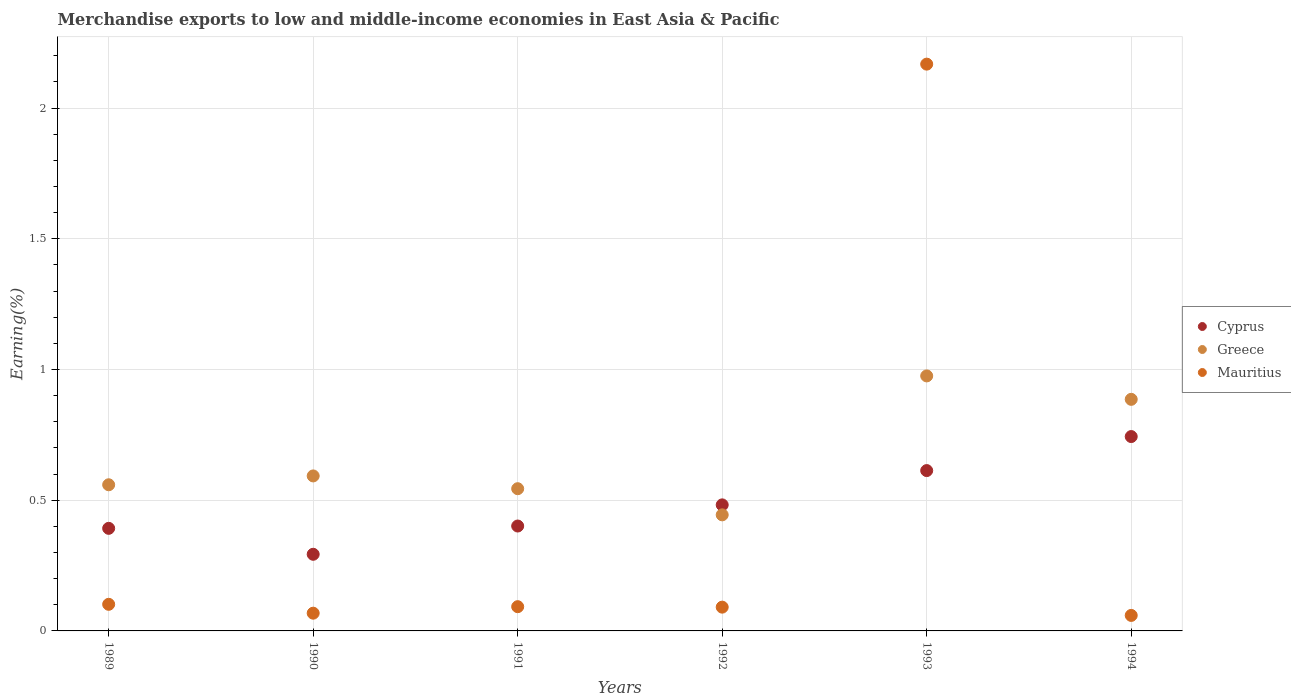Is the number of dotlines equal to the number of legend labels?
Your answer should be very brief. Yes. What is the percentage of amount earned from merchandise exports in Mauritius in 1994?
Provide a short and direct response. 0.06. Across all years, what is the maximum percentage of amount earned from merchandise exports in Cyprus?
Offer a very short reply. 0.74. Across all years, what is the minimum percentage of amount earned from merchandise exports in Mauritius?
Make the answer very short. 0.06. What is the total percentage of amount earned from merchandise exports in Mauritius in the graph?
Give a very brief answer. 2.58. What is the difference between the percentage of amount earned from merchandise exports in Cyprus in 1989 and that in 1991?
Your answer should be compact. -0.01. What is the difference between the percentage of amount earned from merchandise exports in Cyprus in 1991 and the percentage of amount earned from merchandise exports in Greece in 1992?
Offer a terse response. -0.04. What is the average percentage of amount earned from merchandise exports in Greece per year?
Make the answer very short. 0.67. In the year 1992, what is the difference between the percentage of amount earned from merchandise exports in Cyprus and percentage of amount earned from merchandise exports in Mauritius?
Provide a short and direct response. 0.39. In how many years, is the percentage of amount earned from merchandise exports in Mauritius greater than 0.30000000000000004 %?
Provide a short and direct response. 1. What is the ratio of the percentage of amount earned from merchandise exports in Greece in 1993 to that in 1994?
Make the answer very short. 1.1. Is the percentage of amount earned from merchandise exports in Greece in 1989 less than that in 1992?
Give a very brief answer. No. What is the difference between the highest and the second highest percentage of amount earned from merchandise exports in Greece?
Provide a short and direct response. 0.09. What is the difference between the highest and the lowest percentage of amount earned from merchandise exports in Greece?
Your answer should be very brief. 0.53. Is the sum of the percentage of amount earned from merchandise exports in Greece in 1990 and 1993 greater than the maximum percentage of amount earned from merchandise exports in Cyprus across all years?
Keep it short and to the point. Yes. Is the percentage of amount earned from merchandise exports in Cyprus strictly greater than the percentage of amount earned from merchandise exports in Mauritius over the years?
Your response must be concise. No. How many dotlines are there?
Make the answer very short. 3. What is the difference between two consecutive major ticks on the Y-axis?
Your response must be concise. 0.5. Does the graph contain any zero values?
Your answer should be compact. No. Where does the legend appear in the graph?
Make the answer very short. Center right. How many legend labels are there?
Provide a short and direct response. 3. How are the legend labels stacked?
Provide a short and direct response. Vertical. What is the title of the graph?
Your answer should be compact. Merchandise exports to low and middle-income economies in East Asia & Pacific. Does "Tonga" appear as one of the legend labels in the graph?
Your response must be concise. No. What is the label or title of the Y-axis?
Give a very brief answer. Earning(%). What is the Earning(%) in Cyprus in 1989?
Offer a very short reply. 0.39. What is the Earning(%) of Greece in 1989?
Offer a terse response. 0.56. What is the Earning(%) in Mauritius in 1989?
Offer a very short reply. 0.1. What is the Earning(%) in Cyprus in 1990?
Offer a terse response. 0.29. What is the Earning(%) in Greece in 1990?
Offer a very short reply. 0.59. What is the Earning(%) of Mauritius in 1990?
Your answer should be compact. 0.07. What is the Earning(%) of Cyprus in 1991?
Make the answer very short. 0.4. What is the Earning(%) of Greece in 1991?
Ensure brevity in your answer.  0.54. What is the Earning(%) in Mauritius in 1991?
Ensure brevity in your answer.  0.09. What is the Earning(%) of Cyprus in 1992?
Provide a short and direct response. 0.48. What is the Earning(%) in Greece in 1992?
Your response must be concise. 0.44. What is the Earning(%) of Mauritius in 1992?
Your response must be concise. 0.09. What is the Earning(%) of Cyprus in 1993?
Ensure brevity in your answer.  0.61. What is the Earning(%) of Greece in 1993?
Offer a very short reply. 0.98. What is the Earning(%) in Mauritius in 1993?
Your response must be concise. 2.17. What is the Earning(%) in Cyprus in 1994?
Your answer should be very brief. 0.74. What is the Earning(%) of Greece in 1994?
Your answer should be very brief. 0.89. What is the Earning(%) in Mauritius in 1994?
Provide a succinct answer. 0.06. Across all years, what is the maximum Earning(%) of Cyprus?
Make the answer very short. 0.74. Across all years, what is the maximum Earning(%) in Greece?
Ensure brevity in your answer.  0.98. Across all years, what is the maximum Earning(%) of Mauritius?
Offer a very short reply. 2.17. Across all years, what is the minimum Earning(%) in Cyprus?
Your answer should be very brief. 0.29. Across all years, what is the minimum Earning(%) in Greece?
Provide a short and direct response. 0.44. Across all years, what is the minimum Earning(%) in Mauritius?
Offer a terse response. 0.06. What is the total Earning(%) in Cyprus in the graph?
Your answer should be compact. 2.93. What is the total Earning(%) of Greece in the graph?
Your answer should be very brief. 4. What is the total Earning(%) in Mauritius in the graph?
Give a very brief answer. 2.58. What is the difference between the Earning(%) in Cyprus in 1989 and that in 1990?
Ensure brevity in your answer.  0.1. What is the difference between the Earning(%) of Greece in 1989 and that in 1990?
Offer a very short reply. -0.03. What is the difference between the Earning(%) in Mauritius in 1989 and that in 1990?
Ensure brevity in your answer.  0.03. What is the difference between the Earning(%) of Cyprus in 1989 and that in 1991?
Provide a short and direct response. -0.01. What is the difference between the Earning(%) of Greece in 1989 and that in 1991?
Your answer should be compact. 0.01. What is the difference between the Earning(%) in Mauritius in 1989 and that in 1991?
Your answer should be compact. 0.01. What is the difference between the Earning(%) of Cyprus in 1989 and that in 1992?
Provide a short and direct response. -0.09. What is the difference between the Earning(%) of Greece in 1989 and that in 1992?
Keep it short and to the point. 0.12. What is the difference between the Earning(%) of Mauritius in 1989 and that in 1992?
Keep it short and to the point. 0.01. What is the difference between the Earning(%) of Cyprus in 1989 and that in 1993?
Your answer should be very brief. -0.22. What is the difference between the Earning(%) of Greece in 1989 and that in 1993?
Ensure brevity in your answer.  -0.42. What is the difference between the Earning(%) of Mauritius in 1989 and that in 1993?
Provide a succinct answer. -2.07. What is the difference between the Earning(%) in Cyprus in 1989 and that in 1994?
Give a very brief answer. -0.35. What is the difference between the Earning(%) of Greece in 1989 and that in 1994?
Offer a terse response. -0.33. What is the difference between the Earning(%) in Mauritius in 1989 and that in 1994?
Keep it short and to the point. 0.04. What is the difference between the Earning(%) of Cyprus in 1990 and that in 1991?
Provide a short and direct response. -0.11. What is the difference between the Earning(%) in Greece in 1990 and that in 1991?
Ensure brevity in your answer.  0.05. What is the difference between the Earning(%) in Mauritius in 1990 and that in 1991?
Give a very brief answer. -0.02. What is the difference between the Earning(%) of Cyprus in 1990 and that in 1992?
Ensure brevity in your answer.  -0.19. What is the difference between the Earning(%) of Greece in 1990 and that in 1992?
Offer a terse response. 0.15. What is the difference between the Earning(%) in Mauritius in 1990 and that in 1992?
Provide a short and direct response. -0.02. What is the difference between the Earning(%) of Cyprus in 1990 and that in 1993?
Offer a very short reply. -0.32. What is the difference between the Earning(%) in Greece in 1990 and that in 1993?
Make the answer very short. -0.38. What is the difference between the Earning(%) in Mauritius in 1990 and that in 1993?
Offer a terse response. -2.1. What is the difference between the Earning(%) of Cyprus in 1990 and that in 1994?
Your answer should be compact. -0.45. What is the difference between the Earning(%) of Greece in 1990 and that in 1994?
Your answer should be very brief. -0.29. What is the difference between the Earning(%) of Mauritius in 1990 and that in 1994?
Your answer should be compact. 0.01. What is the difference between the Earning(%) of Cyprus in 1991 and that in 1992?
Ensure brevity in your answer.  -0.08. What is the difference between the Earning(%) of Mauritius in 1991 and that in 1992?
Your answer should be compact. 0. What is the difference between the Earning(%) of Cyprus in 1991 and that in 1993?
Keep it short and to the point. -0.21. What is the difference between the Earning(%) of Greece in 1991 and that in 1993?
Give a very brief answer. -0.43. What is the difference between the Earning(%) of Mauritius in 1991 and that in 1993?
Provide a succinct answer. -2.08. What is the difference between the Earning(%) in Cyprus in 1991 and that in 1994?
Offer a very short reply. -0.34. What is the difference between the Earning(%) in Greece in 1991 and that in 1994?
Offer a very short reply. -0.34. What is the difference between the Earning(%) in Mauritius in 1991 and that in 1994?
Give a very brief answer. 0.03. What is the difference between the Earning(%) of Cyprus in 1992 and that in 1993?
Offer a very short reply. -0.13. What is the difference between the Earning(%) in Greece in 1992 and that in 1993?
Give a very brief answer. -0.53. What is the difference between the Earning(%) of Mauritius in 1992 and that in 1993?
Your answer should be very brief. -2.08. What is the difference between the Earning(%) in Cyprus in 1992 and that in 1994?
Your response must be concise. -0.26. What is the difference between the Earning(%) in Greece in 1992 and that in 1994?
Keep it short and to the point. -0.44. What is the difference between the Earning(%) of Mauritius in 1992 and that in 1994?
Provide a succinct answer. 0.03. What is the difference between the Earning(%) in Cyprus in 1993 and that in 1994?
Offer a very short reply. -0.13. What is the difference between the Earning(%) of Greece in 1993 and that in 1994?
Your answer should be compact. 0.09. What is the difference between the Earning(%) of Mauritius in 1993 and that in 1994?
Your answer should be very brief. 2.11. What is the difference between the Earning(%) of Cyprus in 1989 and the Earning(%) of Greece in 1990?
Keep it short and to the point. -0.2. What is the difference between the Earning(%) of Cyprus in 1989 and the Earning(%) of Mauritius in 1990?
Offer a very short reply. 0.32. What is the difference between the Earning(%) of Greece in 1989 and the Earning(%) of Mauritius in 1990?
Your answer should be very brief. 0.49. What is the difference between the Earning(%) of Cyprus in 1989 and the Earning(%) of Greece in 1991?
Give a very brief answer. -0.15. What is the difference between the Earning(%) of Cyprus in 1989 and the Earning(%) of Mauritius in 1991?
Offer a terse response. 0.3. What is the difference between the Earning(%) in Greece in 1989 and the Earning(%) in Mauritius in 1991?
Make the answer very short. 0.47. What is the difference between the Earning(%) in Cyprus in 1989 and the Earning(%) in Greece in 1992?
Provide a short and direct response. -0.05. What is the difference between the Earning(%) in Cyprus in 1989 and the Earning(%) in Mauritius in 1992?
Ensure brevity in your answer.  0.3. What is the difference between the Earning(%) of Greece in 1989 and the Earning(%) of Mauritius in 1992?
Give a very brief answer. 0.47. What is the difference between the Earning(%) in Cyprus in 1989 and the Earning(%) in Greece in 1993?
Keep it short and to the point. -0.58. What is the difference between the Earning(%) in Cyprus in 1989 and the Earning(%) in Mauritius in 1993?
Make the answer very short. -1.78. What is the difference between the Earning(%) in Greece in 1989 and the Earning(%) in Mauritius in 1993?
Your answer should be compact. -1.61. What is the difference between the Earning(%) in Cyprus in 1989 and the Earning(%) in Greece in 1994?
Make the answer very short. -0.49. What is the difference between the Earning(%) of Cyprus in 1989 and the Earning(%) of Mauritius in 1994?
Your answer should be compact. 0.33. What is the difference between the Earning(%) in Greece in 1989 and the Earning(%) in Mauritius in 1994?
Provide a short and direct response. 0.5. What is the difference between the Earning(%) of Cyprus in 1990 and the Earning(%) of Greece in 1991?
Make the answer very short. -0.25. What is the difference between the Earning(%) of Cyprus in 1990 and the Earning(%) of Mauritius in 1991?
Offer a terse response. 0.2. What is the difference between the Earning(%) of Greece in 1990 and the Earning(%) of Mauritius in 1991?
Offer a terse response. 0.5. What is the difference between the Earning(%) of Cyprus in 1990 and the Earning(%) of Greece in 1992?
Provide a succinct answer. -0.15. What is the difference between the Earning(%) of Cyprus in 1990 and the Earning(%) of Mauritius in 1992?
Give a very brief answer. 0.2. What is the difference between the Earning(%) in Greece in 1990 and the Earning(%) in Mauritius in 1992?
Your response must be concise. 0.5. What is the difference between the Earning(%) in Cyprus in 1990 and the Earning(%) in Greece in 1993?
Your answer should be very brief. -0.68. What is the difference between the Earning(%) in Cyprus in 1990 and the Earning(%) in Mauritius in 1993?
Keep it short and to the point. -1.88. What is the difference between the Earning(%) of Greece in 1990 and the Earning(%) of Mauritius in 1993?
Ensure brevity in your answer.  -1.58. What is the difference between the Earning(%) in Cyprus in 1990 and the Earning(%) in Greece in 1994?
Provide a short and direct response. -0.59. What is the difference between the Earning(%) of Cyprus in 1990 and the Earning(%) of Mauritius in 1994?
Your answer should be very brief. 0.23. What is the difference between the Earning(%) in Greece in 1990 and the Earning(%) in Mauritius in 1994?
Your answer should be compact. 0.53. What is the difference between the Earning(%) in Cyprus in 1991 and the Earning(%) in Greece in 1992?
Ensure brevity in your answer.  -0.04. What is the difference between the Earning(%) in Cyprus in 1991 and the Earning(%) in Mauritius in 1992?
Keep it short and to the point. 0.31. What is the difference between the Earning(%) of Greece in 1991 and the Earning(%) of Mauritius in 1992?
Your answer should be very brief. 0.45. What is the difference between the Earning(%) of Cyprus in 1991 and the Earning(%) of Greece in 1993?
Keep it short and to the point. -0.57. What is the difference between the Earning(%) of Cyprus in 1991 and the Earning(%) of Mauritius in 1993?
Offer a terse response. -1.77. What is the difference between the Earning(%) of Greece in 1991 and the Earning(%) of Mauritius in 1993?
Offer a very short reply. -1.62. What is the difference between the Earning(%) of Cyprus in 1991 and the Earning(%) of Greece in 1994?
Make the answer very short. -0.48. What is the difference between the Earning(%) in Cyprus in 1991 and the Earning(%) in Mauritius in 1994?
Your response must be concise. 0.34. What is the difference between the Earning(%) of Greece in 1991 and the Earning(%) of Mauritius in 1994?
Offer a very short reply. 0.48. What is the difference between the Earning(%) of Cyprus in 1992 and the Earning(%) of Greece in 1993?
Your answer should be compact. -0.49. What is the difference between the Earning(%) in Cyprus in 1992 and the Earning(%) in Mauritius in 1993?
Give a very brief answer. -1.69. What is the difference between the Earning(%) of Greece in 1992 and the Earning(%) of Mauritius in 1993?
Your answer should be compact. -1.72. What is the difference between the Earning(%) in Cyprus in 1992 and the Earning(%) in Greece in 1994?
Provide a short and direct response. -0.4. What is the difference between the Earning(%) of Cyprus in 1992 and the Earning(%) of Mauritius in 1994?
Give a very brief answer. 0.42. What is the difference between the Earning(%) of Greece in 1992 and the Earning(%) of Mauritius in 1994?
Make the answer very short. 0.38. What is the difference between the Earning(%) in Cyprus in 1993 and the Earning(%) in Greece in 1994?
Ensure brevity in your answer.  -0.27. What is the difference between the Earning(%) of Cyprus in 1993 and the Earning(%) of Mauritius in 1994?
Provide a succinct answer. 0.55. What is the difference between the Earning(%) of Greece in 1993 and the Earning(%) of Mauritius in 1994?
Ensure brevity in your answer.  0.92. What is the average Earning(%) of Cyprus per year?
Ensure brevity in your answer.  0.49. What is the average Earning(%) in Greece per year?
Make the answer very short. 0.67. What is the average Earning(%) in Mauritius per year?
Give a very brief answer. 0.43. In the year 1989, what is the difference between the Earning(%) in Cyprus and Earning(%) in Mauritius?
Your answer should be very brief. 0.29. In the year 1989, what is the difference between the Earning(%) of Greece and Earning(%) of Mauritius?
Offer a terse response. 0.46. In the year 1990, what is the difference between the Earning(%) in Cyprus and Earning(%) in Greece?
Make the answer very short. -0.3. In the year 1990, what is the difference between the Earning(%) in Cyprus and Earning(%) in Mauritius?
Give a very brief answer. 0.23. In the year 1990, what is the difference between the Earning(%) in Greece and Earning(%) in Mauritius?
Provide a succinct answer. 0.53. In the year 1991, what is the difference between the Earning(%) of Cyprus and Earning(%) of Greece?
Provide a succinct answer. -0.14. In the year 1991, what is the difference between the Earning(%) of Cyprus and Earning(%) of Mauritius?
Offer a terse response. 0.31. In the year 1991, what is the difference between the Earning(%) of Greece and Earning(%) of Mauritius?
Your answer should be very brief. 0.45. In the year 1992, what is the difference between the Earning(%) in Cyprus and Earning(%) in Greece?
Offer a very short reply. 0.04. In the year 1992, what is the difference between the Earning(%) of Cyprus and Earning(%) of Mauritius?
Your answer should be compact. 0.39. In the year 1992, what is the difference between the Earning(%) of Greece and Earning(%) of Mauritius?
Provide a succinct answer. 0.35. In the year 1993, what is the difference between the Earning(%) in Cyprus and Earning(%) in Greece?
Your response must be concise. -0.36. In the year 1993, what is the difference between the Earning(%) of Cyprus and Earning(%) of Mauritius?
Give a very brief answer. -1.55. In the year 1993, what is the difference between the Earning(%) in Greece and Earning(%) in Mauritius?
Make the answer very short. -1.19. In the year 1994, what is the difference between the Earning(%) in Cyprus and Earning(%) in Greece?
Make the answer very short. -0.14. In the year 1994, what is the difference between the Earning(%) of Cyprus and Earning(%) of Mauritius?
Your answer should be very brief. 0.68. In the year 1994, what is the difference between the Earning(%) in Greece and Earning(%) in Mauritius?
Your response must be concise. 0.83. What is the ratio of the Earning(%) of Cyprus in 1989 to that in 1990?
Give a very brief answer. 1.34. What is the ratio of the Earning(%) in Greece in 1989 to that in 1990?
Ensure brevity in your answer.  0.94. What is the ratio of the Earning(%) in Mauritius in 1989 to that in 1990?
Your answer should be very brief. 1.5. What is the ratio of the Earning(%) in Cyprus in 1989 to that in 1991?
Your answer should be compact. 0.98. What is the ratio of the Earning(%) of Greece in 1989 to that in 1991?
Provide a succinct answer. 1.03. What is the ratio of the Earning(%) of Mauritius in 1989 to that in 1991?
Give a very brief answer. 1.1. What is the ratio of the Earning(%) in Cyprus in 1989 to that in 1992?
Your response must be concise. 0.81. What is the ratio of the Earning(%) of Greece in 1989 to that in 1992?
Ensure brevity in your answer.  1.26. What is the ratio of the Earning(%) in Mauritius in 1989 to that in 1992?
Provide a succinct answer. 1.12. What is the ratio of the Earning(%) in Cyprus in 1989 to that in 1993?
Offer a terse response. 0.64. What is the ratio of the Earning(%) of Greece in 1989 to that in 1993?
Offer a very short reply. 0.57. What is the ratio of the Earning(%) in Mauritius in 1989 to that in 1993?
Provide a succinct answer. 0.05. What is the ratio of the Earning(%) in Cyprus in 1989 to that in 1994?
Offer a very short reply. 0.53. What is the ratio of the Earning(%) of Greece in 1989 to that in 1994?
Your answer should be very brief. 0.63. What is the ratio of the Earning(%) of Mauritius in 1989 to that in 1994?
Your response must be concise. 1.72. What is the ratio of the Earning(%) in Cyprus in 1990 to that in 1991?
Your answer should be compact. 0.73. What is the ratio of the Earning(%) in Greece in 1990 to that in 1991?
Your response must be concise. 1.09. What is the ratio of the Earning(%) in Mauritius in 1990 to that in 1991?
Your answer should be compact. 0.73. What is the ratio of the Earning(%) in Cyprus in 1990 to that in 1992?
Your response must be concise. 0.61. What is the ratio of the Earning(%) of Greece in 1990 to that in 1992?
Offer a terse response. 1.34. What is the ratio of the Earning(%) of Mauritius in 1990 to that in 1992?
Your answer should be very brief. 0.75. What is the ratio of the Earning(%) in Cyprus in 1990 to that in 1993?
Keep it short and to the point. 0.48. What is the ratio of the Earning(%) in Greece in 1990 to that in 1993?
Offer a very short reply. 0.61. What is the ratio of the Earning(%) in Mauritius in 1990 to that in 1993?
Your answer should be very brief. 0.03. What is the ratio of the Earning(%) of Cyprus in 1990 to that in 1994?
Provide a short and direct response. 0.39. What is the ratio of the Earning(%) in Greece in 1990 to that in 1994?
Provide a short and direct response. 0.67. What is the ratio of the Earning(%) in Mauritius in 1990 to that in 1994?
Offer a very short reply. 1.14. What is the ratio of the Earning(%) in Cyprus in 1991 to that in 1992?
Your answer should be very brief. 0.83. What is the ratio of the Earning(%) of Greece in 1991 to that in 1992?
Keep it short and to the point. 1.23. What is the ratio of the Earning(%) in Mauritius in 1991 to that in 1992?
Offer a terse response. 1.02. What is the ratio of the Earning(%) in Cyprus in 1991 to that in 1993?
Ensure brevity in your answer.  0.65. What is the ratio of the Earning(%) in Greece in 1991 to that in 1993?
Provide a short and direct response. 0.56. What is the ratio of the Earning(%) in Mauritius in 1991 to that in 1993?
Offer a very short reply. 0.04. What is the ratio of the Earning(%) in Cyprus in 1991 to that in 1994?
Provide a short and direct response. 0.54. What is the ratio of the Earning(%) of Greece in 1991 to that in 1994?
Your answer should be very brief. 0.61. What is the ratio of the Earning(%) in Mauritius in 1991 to that in 1994?
Your answer should be compact. 1.56. What is the ratio of the Earning(%) of Cyprus in 1992 to that in 1993?
Your response must be concise. 0.79. What is the ratio of the Earning(%) in Greece in 1992 to that in 1993?
Offer a very short reply. 0.46. What is the ratio of the Earning(%) in Mauritius in 1992 to that in 1993?
Give a very brief answer. 0.04. What is the ratio of the Earning(%) in Cyprus in 1992 to that in 1994?
Provide a succinct answer. 0.65. What is the ratio of the Earning(%) of Greece in 1992 to that in 1994?
Provide a short and direct response. 0.5. What is the ratio of the Earning(%) of Mauritius in 1992 to that in 1994?
Offer a very short reply. 1.53. What is the ratio of the Earning(%) of Cyprus in 1993 to that in 1994?
Provide a succinct answer. 0.82. What is the ratio of the Earning(%) of Greece in 1993 to that in 1994?
Keep it short and to the point. 1.1. What is the ratio of the Earning(%) of Mauritius in 1993 to that in 1994?
Offer a very short reply. 36.57. What is the difference between the highest and the second highest Earning(%) of Cyprus?
Your answer should be compact. 0.13. What is the difference between the highest and the second highest Earning(%) in Greece?
Your answer should be very brief. 0.09. What is the difference between the highest and the second highest Earning(%) in Mauritius?
Give a very brief answer. 2.07. What is the difference between the highest and the lowest Earning(%) in Cyprus?
Provide a succinct answer. 0.45. What is the difference between the highest and the lowest Earning(%) in Greece?
Your answer should be very brief. 0.53. What is the difference between the highest and the lowest Earning(%) of Mauritius?
Offer a very short reply. 2.11. 